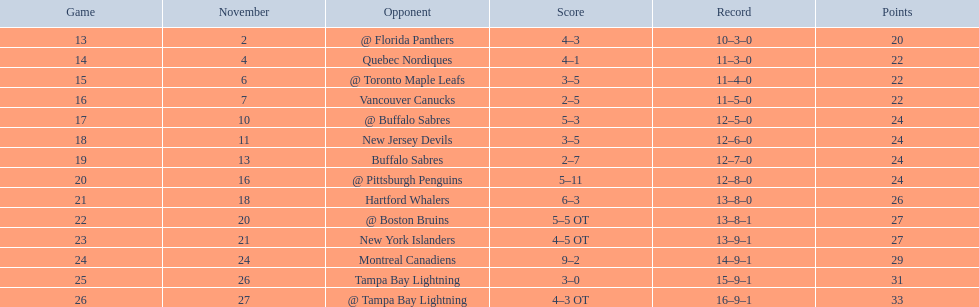Who were the opponents of the philadelphia flyers in the 17th match? @ Buffalo Sabres. What was the outcome of the november 10th match versus the buffalo sabres? 5–3. Which squad in the atlantic division had fewer points than the philadelphia flyers? Tampa Bay Lightning. 